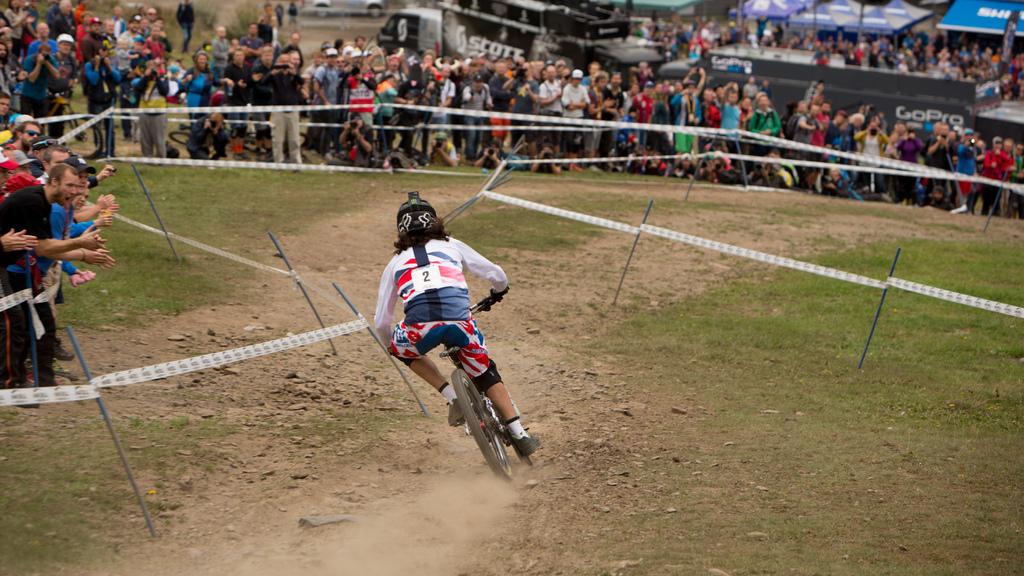What is the biker's jersey number?
Provide a succinct answer. 2. 